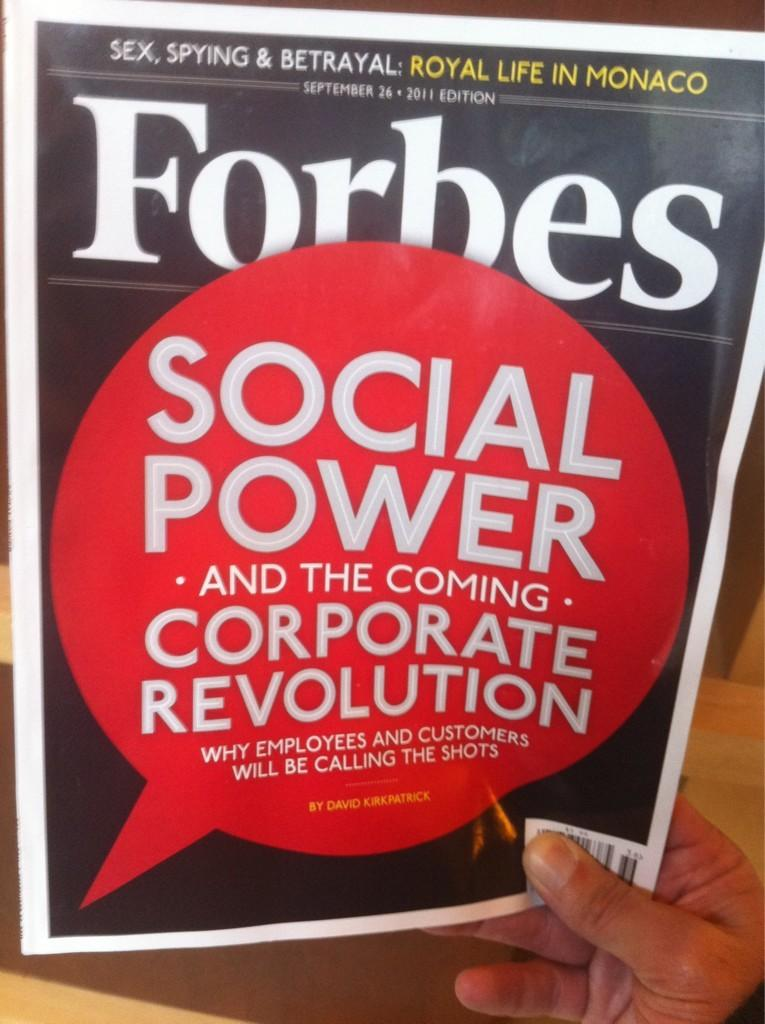<image>
Create a compact narrative representing the image presented. a paper that says 'forbes' on the cover of it 